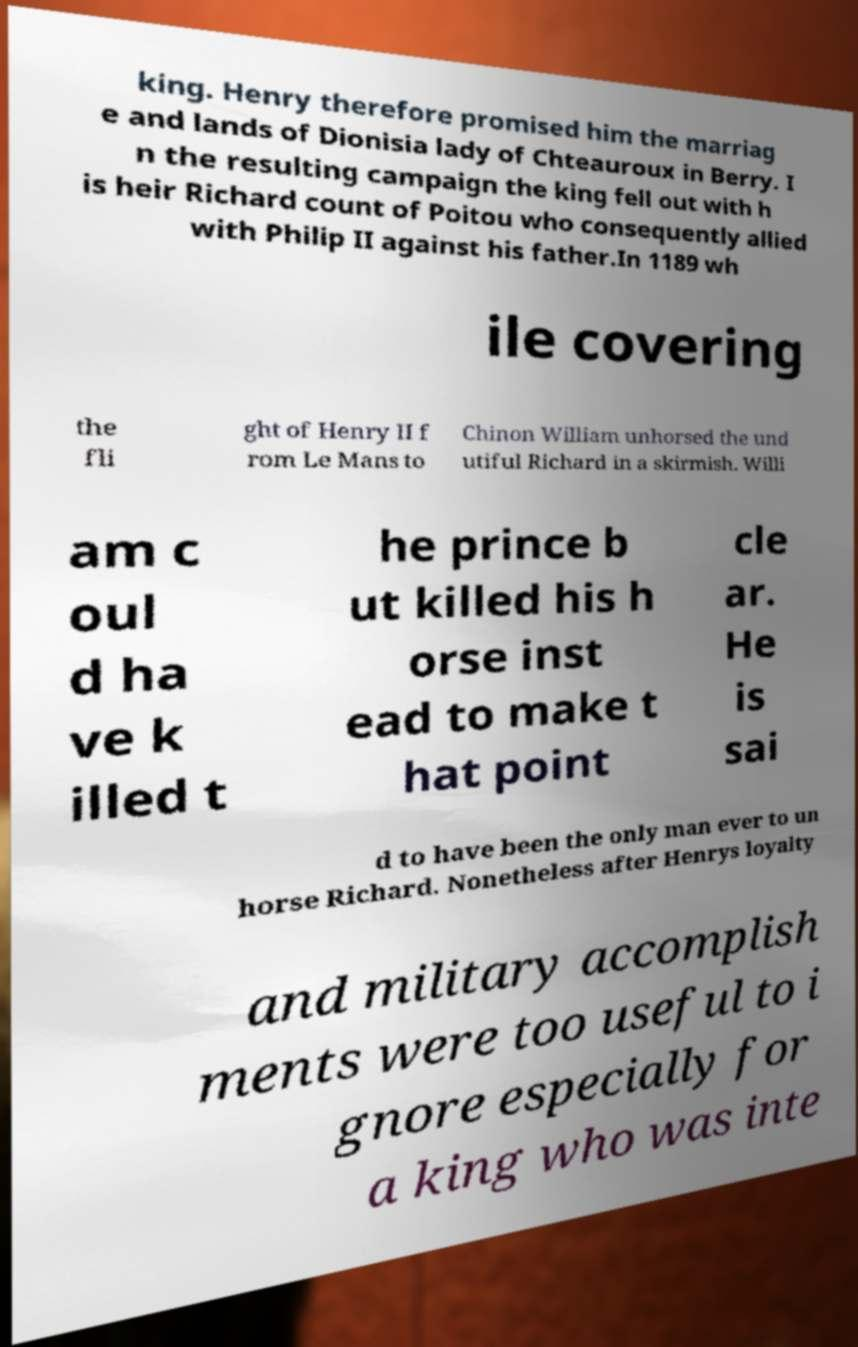There's text embedded in this image that I need extracted. Can you transcribe it verbatim? king. Henry therefore promised him the marriag e and lands of Dionisia lady of Chteauroux in Berry. I n the resulting campaign the king fell out with h is heir Richard count of Poitou who consequently allied with Philip II against his father.In 1189 wh ile covering the fli ght of Henry II f rom Le Mans to Chinon William unhorsed the und utiful Richard in a skirmish. Willi am c oul d ha ve k illed t he prince b ut killed his h orse inst ead to make t hat point cle ar. He is sai d to have been the only man ever to un horse Richard. Nonetheless after Henrys loyalty and military accomplish ments were too useful to i gnore especially for a king who was inte 